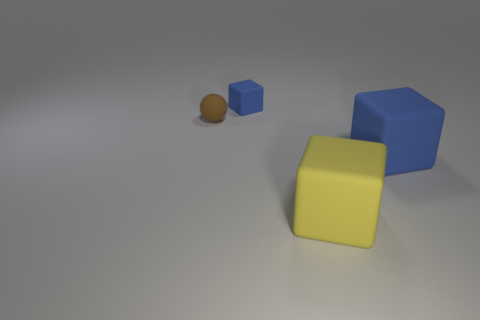There is a cube behind the large blue object; is it the same color as the cube to the right of the large yellow matte cube?
Your answer should be very brief. Yes. Are there any big objects?
Keep it short and to the point. Yes. Is there a yellow block made of the same material as the large blue block?
Your answer should be compact. Yes. The rubber sphere has what color?
Provide a succinct answer. Brown. What shape is the object that is the same color as the tiny matte cube?
Your response must be concise. Cube. The other rubber cube that is the same size as the yellow matte cube is what color?
Offer a terse response. Blue. How many metal objects are large things or large brown cubes?
Make the answer very short. 0. What number of objects are both to the right of the small rubber sphere and behind the big yellow cube?
Your response must be concise. 2. Is there anything else that has the same shape as the big yellow rubber object?
Your answer should be compact. Yes. How many other objects are there of the same size as the brown ball?
Give a very brief answer. 1. 